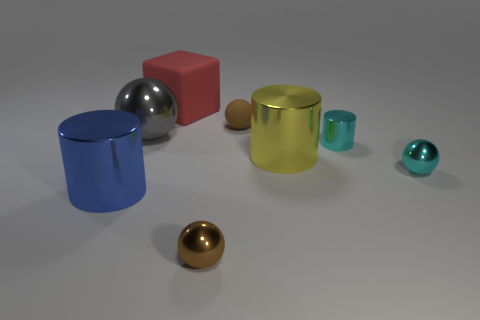Add 1 gray shiny spheres. How many objects exist? 9 Subtract all cubes. How many objects are left? 7 Subtract 0 green cubes. How many objects are left? 8 Subtract all brown rubber balls. Subtract all gray things. How many objects are left? 6 Add 8 matte cubes. How many matte cubes are left? 9 Add 7 small brown shiny objects. How many small brown shiny objects exist? 8 